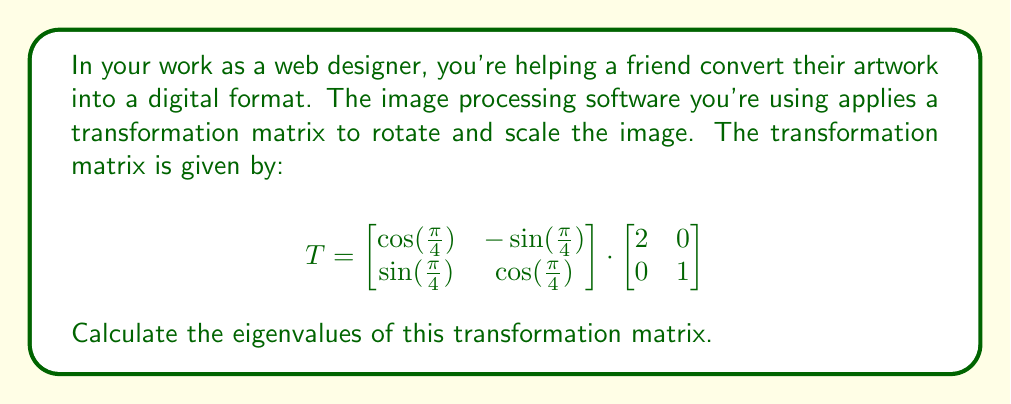Solve this math problem. To find the eigenvalues of the transformation matrix T, we need to follow these steps:

1) First, let's multiply the two matrices to get T:

   $$T = \begin{bmatrix}
   \frac{\sqrt{2}}{2} & -\frac{\sqrt{2}}{2} \\
   \frac{\sqrt{2}}{2} & \frac{\sqrt{2}}{2}
   \end{bmatrix} \cdot \begin{bmatrix}
   2 & 0 \\
   0 & 1
   \end{bmatrix} = \begin{bmatrix}
   \sqrt{2} & -\frac{\sqrt{2}}{2} \\
   \sqrt{2} & \frac{\sqrt{2}}{2}
   \end{bmatrix}$$

2) To find the eigenvalues, we need to solve the characteristic equation:
   $\det(T - \lambda I) = 0$, where I is the 2x2 identity matrix.

3) Let's set up this equation:

   $$\det\begin{pmatrix}
   \sqrt{2} - \lambda & -\frac{\sqrt{2}}{2} \\
   \sqrt{2} & \frac{\sqrt{2}}{2} - \lambda
   \end{pmatrix} = 0$$

4) Expanding the determinant:

   $$(\sqrt{2} - \lambda)(\frac{\sqrt{2}}{2} - \lambda) - (-\frac{\sqrt{2}}{2})(\sqrt{2}) = 0$$

5) Simplifying:

   $$\frac{1}{2}(2 - \sqrt{2}\lambda - \sqrt{2}\lambda + \lambda^2) - 1 = 0$$
   $$2 - 2\sqrt{2}\lambda + \lambda^2 - 2 = 0$$
   $$\lambda^2 - 2\sqrt{2}\lambda = 0$$

6) Factoring out $\lambda$:

   $$\lambda(\lambda - 2\sqrt{2}) = 0$$

7) Solving this equation, we get:
   $\lambda = 0$ or $\lambda = 2\sqrt{2}$

These are the eigenvalues of the transformation matrix.
Answer: $\lambda_1 = 0$, $\lambda_2 = 2\sqrt{2}$ 